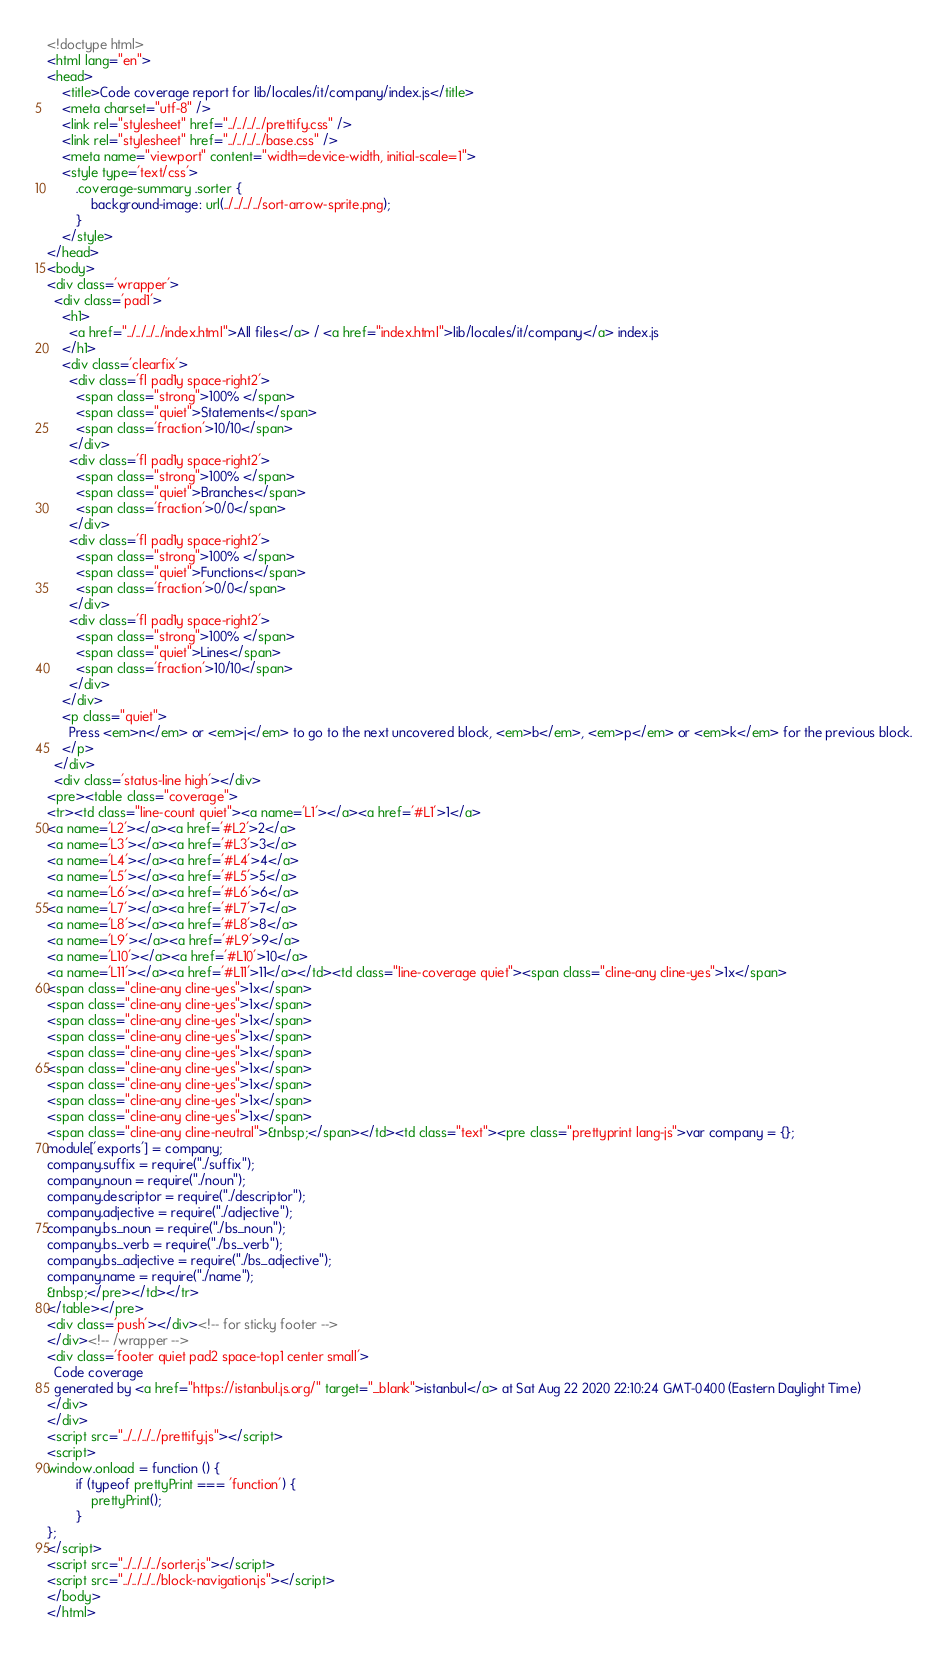Convert code to text. <code><loc_0><loc_0><loc_500><loc_500><_HTML_><!doctype html>
<html lang="en">
<head>
    <title>Code coverage report for lib/locales/it/company/index.js</title>
    <meta charset="utf-8" />
    <link rel="stylesheet" href="../../../../prettify.css" />
    <link rel="stylesheet" href="../../../../base.css" />
    <meta name="viewport" content="width=device-width, initial-scale=1">
    <style type='text/css'>
        .coverage-summary .sorter {
            background-image: url(../../../../sort-arrow-sprite.png);
        }
    </style>
</head>
<body>
<div class='wrapper'>
  <div class='pad1'>
    <h1>
      <a href="../../../../index.html">All files</a> / <a href="index.html">lib/locales/it/company</a> index.js
    </h1>
    <div class='clearfix'>
      <div class='fl pad1y space-right2'>
        <span class="strong">100% </span>
        <span class="quiet">Statements</span>
        <span class='fraction'>10/10</span>
      </div>
      <div class='fl pad1y space-right2'>
        <span class="strong">100% </span>
        <span class="quiet">Branches</span>
        <span class='fraction'>0/0</span>
      </div>
      <div class='fl pad1y space-right2'>
        <span class="strong">100% </span>
        <span class="quiet">Functions</span>
        <span class='fraction'>0/0</span>
      </div>
      <div class='fl pad1y space-right2'>
        <span class="strong">100% </span>
        <span class="quiet">Lines</span>
        <span class='fraction'>10/10</span>
      </div>
    </div>
    <p class="quiet">
      Press <em>n</em> or <em>j</em> to go to the next uncovered block, <em>b</em>, <em>p</em> or <em>k</em> for the previous block.
    </p>
  </div>
  <div class='status-line high'></div>
<pre><table class="coverage">
<tr><td class="line-count quiet"><a name='L1'></a><a href='#L1'>1</a>
<a name='L2'></a><a href='#L2'>2</a>
<a name='L3'></a><a href='#L3'>3</a>
<a name='L4'></a><a href='#L4'>4</a>
<a name='L5'></a><a href='#L5'>5</a>
<a name='L6'></a><a href='#L6'>6</a>
<a name='L7'></a><a href='#L7'>7</a>
<a name='L8'></a><a href='#L8'>8</a>
<a name='L9'></a><a href='#L9'>9</a>
<a name='L10'></a><a href='#L10'>10</a>
<a name='L11'></a><a href='#L11'>11</a></td><td class="line-coverage quiet"><span class="cline-any cline-yes">1x</span>
<span class="cline-any cline-yes">1x</span>
<span class="cline-any cline-yes">1x</span>
<span class="cline-any cline-yes">1x</span>
<span class="cline-any cline-yes">1x</span>
<span class="cline-any cline-yes">1x</span>
<span class="cline-any cline-yes">1x</span>
<span class="cline-any cline-yes">1x</span>
<span class="cline-any cline-yes">1x</span>
<span class="cline-any cline-yes">1x</span>
<span class="cline-any cline-neutral">&nbsp;</span></td><td class="text"><pre class="prettyprint lang-js">var company = {};
module['exports'] = company;
company.suffix = require("./suffix");
company.noun = require("./noun");
company.descriptor = require("./descriptor");
company.adjective = require("./adjective");
company.bs_noun = require("./bs_noun");
company.bs_verb = require("./bs_verb");
company.bs_adjective = require("./bs_adjective");
company.name = require("./name");
&nbsp;</pre></td></tr>
</table></pre>
<div class='push'></div><!-- for sticky footer -->
</div><!-- /wrapper -->
<div class='footer quiet pad2 space-top1 center small'>
  Code coverage
  generated by <a href="https://istanbul.js.org/" target="_blank">istanbul</a> at Sat Aug 22 2020 22:10:24 GMT-0400 (Eastern Daylight Time)
</div>
</div>
<script src="../../../../prettify.js"></script>
<script>
window.onload = function () {
        if (typeof prettyPrint === 'function') {
            prettyPrint();
        }
};
</script>
<script src="../../../../sorter.js"></script>
<script src="../../../../block-navigation.js"></script>
</body>
</html>
</code> 